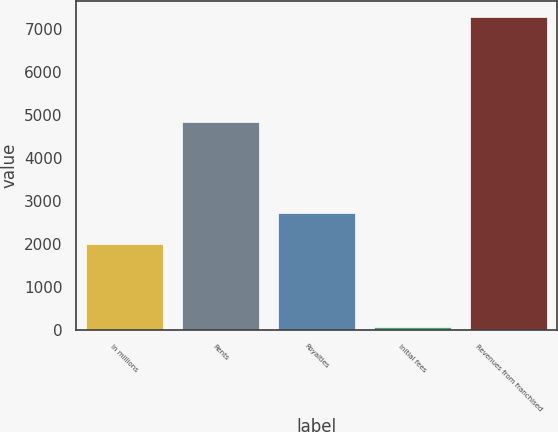Convert chart to OTSL. <chart><loc_0><loc_0><loc_500><loc_500><bar_chart><fcel>In millions<fcel>Rents<fcel>Royalties<fcel>Initial fees<fcel>Revenues from franchised<nl><fcel>2009<fcel>4841<fcel>2731.08<fcel>65.4<fcel>7286.2<nl></chart> 